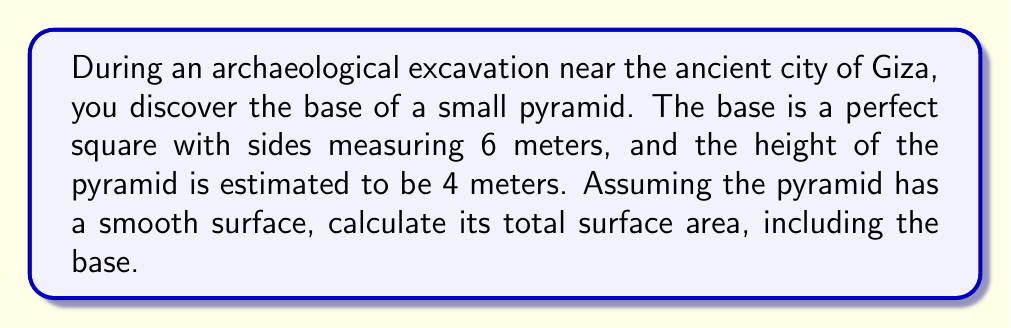Can you answer this question? To solve this problem, we need to follow these steps:

1. Calculate the area of the base
2. Find the length of the pyramid's edge
3. Calculate the area of a triangular face
4. Determine the total surface area

Step 1: Calculate the area of the base
The base is a square with side length 6 meters.
Area of base = $6^2 = 36$ m²

Step 2: Find the length of the pyramid's edge
We can use the Pythagorean theorem to find the length of the edge. Let's call this length $l$.
$$l^2 = (\frac{6\sqrt{2}}{2})^2 + 4^2$$

Here, $\frac{6\sqrt{2}}{2}$ is half the diagonal of the base square.

$$l^2 = 18 + 16 = 34$$
$$l = \sqrt{34} \approx 5.83$ m

Step 3: Calculate the area of a triangular face
The area of a triangle is $\frac{1}{2} \times base \times height$
Base of the triangle is 6 m, and the height is the slant height of the pyramid.

Slant height = $\sqrt{(\frac{6}{2})^2 + 4^2} = \sqrt{9 + 16} = 5$ m

Area of one triangular face = $\frac{1}{2} \times 6 \times 5 = 15$ m²

Step 4: Determine the total surface area
Total surface area = Area of base + (4 × Area of triangular face)
Total surface area = $36 + (4 \times 15) = 36 + 60 = 96$ m²

[asy]
import three;

size(200);
currentprojection=perspective(6,3,2);

triple A=(0,0,0), B=(6,0,0), C=(6,6,0), D=(0,6,0), E=(3,3,4);

draw(A--B--C--D--cycle);
draw(A--E--C,dashed);
draw(B--E--D);

label("A",A,SW);
label("B",B,SE);
label("C",C,NE);
label("D",D,NW);
label("E",E,N);

label("6 m",0.5(A--B),S);
label("4 m",0.5(E--0.5(A+C)),W);
[/asy]
Answer: The total surface area of the pyramid is 96 m². 